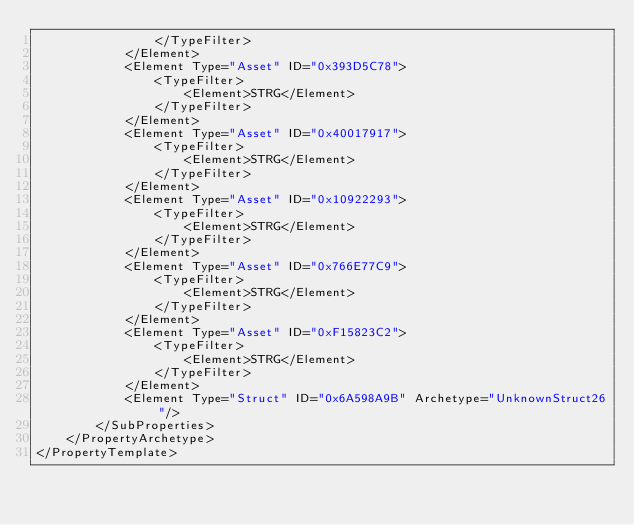<code> <loc_0><loc_0><loc_500><loc_500><_XML_>                </TypeFilter>
            </Element>
            <Element Type="Asset" ID="0x393D5C78">
                <TypeFilter>
                    <Element>STRG</Element>
                </TypeFilter>
            </Element>
            <Element Type="Asset" ID="0x40017917">
                <TypeFilter>
                    <Element>STRG</Element>
                </TypeFilter>
            </Element>
            <Element Type="Asset" ID="0x10922293">
                <TypeFilter>
                    <Element>STRG</Element>
                </TypeFilter>
            </Element>
            <Element Type="Asset" ID="0x766E77C9">
                <TypeFilter>
                    <Element>STRG</Element>
                </TypeFilter>
            </Element>
            <Element Type="Asset" ID="0xF15823C2">
                <TypeFilter>
                    <Element>STRG</Element>
                </TypeFilter>
            </Element>
            <Element Type="Struct" ID="0x6A598A9B" Archetype="UnknownStruct26"/>
        </SubProperties>
    </PropertyArchetype>
</PropertyTemplate>
</code> 